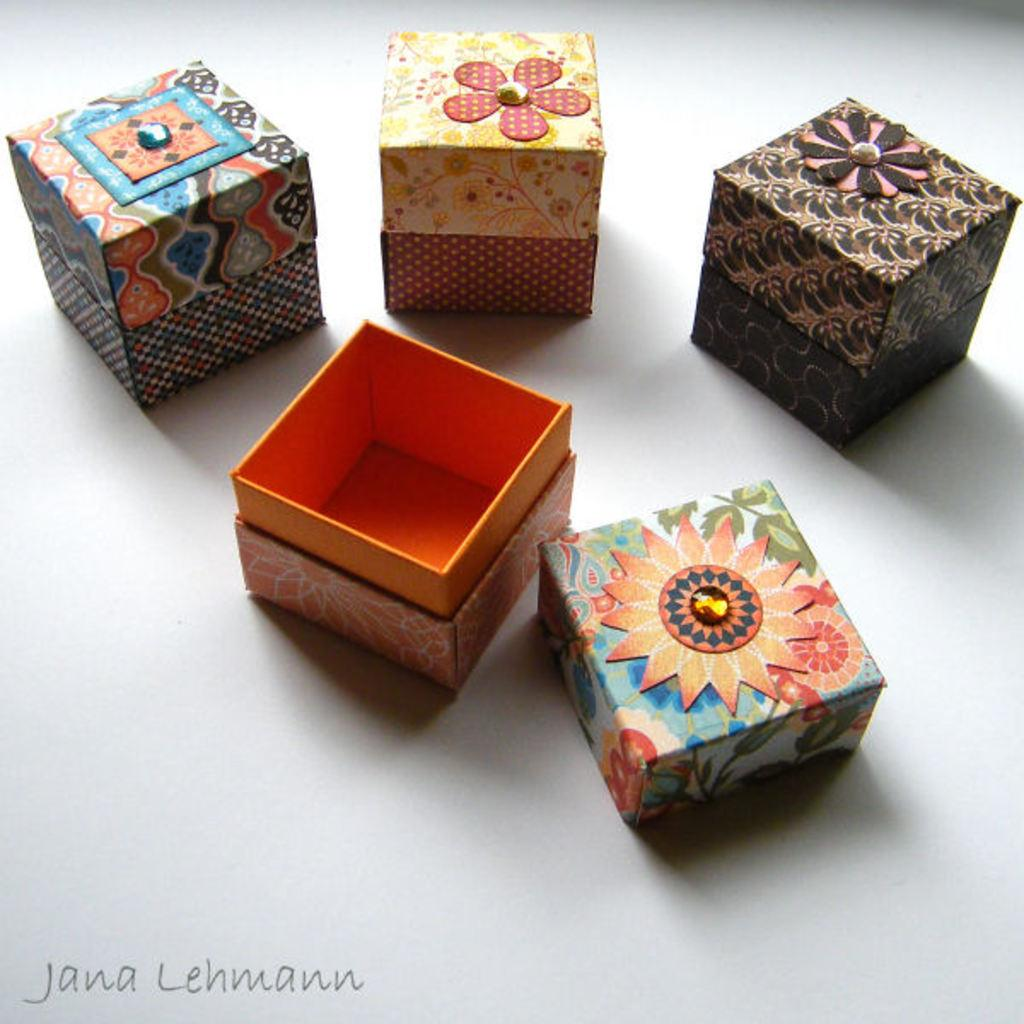<image>
Give a short and clear explanation of the subsequent image. Boxes on a table with the name "Jana Lehmann" near the bottom left. 